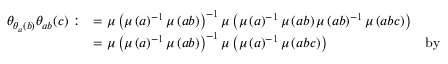<formula> <loc_0><loc_0><loc_500><loc_500>\begin{array} { r l r } { \theta _ { \theta _ { a } ( b ) } \theta _ { a b } ( c ) \colon } & { = \mu \left ( \mu \left ( a \right ) ^ { - 1 } \mu \left ( a b \right ) \right ) ^ { - 1 } \mu \left ( \mu \left ( a \right ) ^ { - 1 } \mu \left ( a b \right ) \mu \left ( a b \right ) ^ { - 1 } \mu \left ( a b c \right ) \right ) } \\ & { = \mu \left ( \mu \left ( a \right ) ^ { - 1 } \mu \left ( a b \right ) \right ) ^ { - 1 } \mu \left ( \mu \left ( a \right ) ^ { - 1 } \mu \left ( a b c \right ) \right ) } & { b y } \end{array}</formula> 